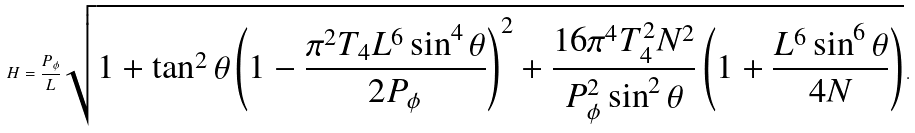<formula> <loc_0><loc_0><loc_500><loc_500>H = \frac { P _ { \phi } } { L } \sqrt { 1 + \tan ^ { 2 } { \theta } \left ( 1 - \frac { \pi ^ { 2 } T _ { 4 } L ^ { 6 } \sin ^ { 4 } { \theta } } { 2 P _ { \phi } } \right ) ^ { 2 } + \frac { 1 6 \pi ^ { 4 } T _ { 4 } ^ { 2 } N ^ { 2 } } { P _ { \phi } ^ { 2 } \sin ^ { 2 } { \theta } } \left ( 1 + \frac { L ^ { 6 } \sin ^ { 6 } { \theta } } { 4 N } \right ) } \, .</formula> 